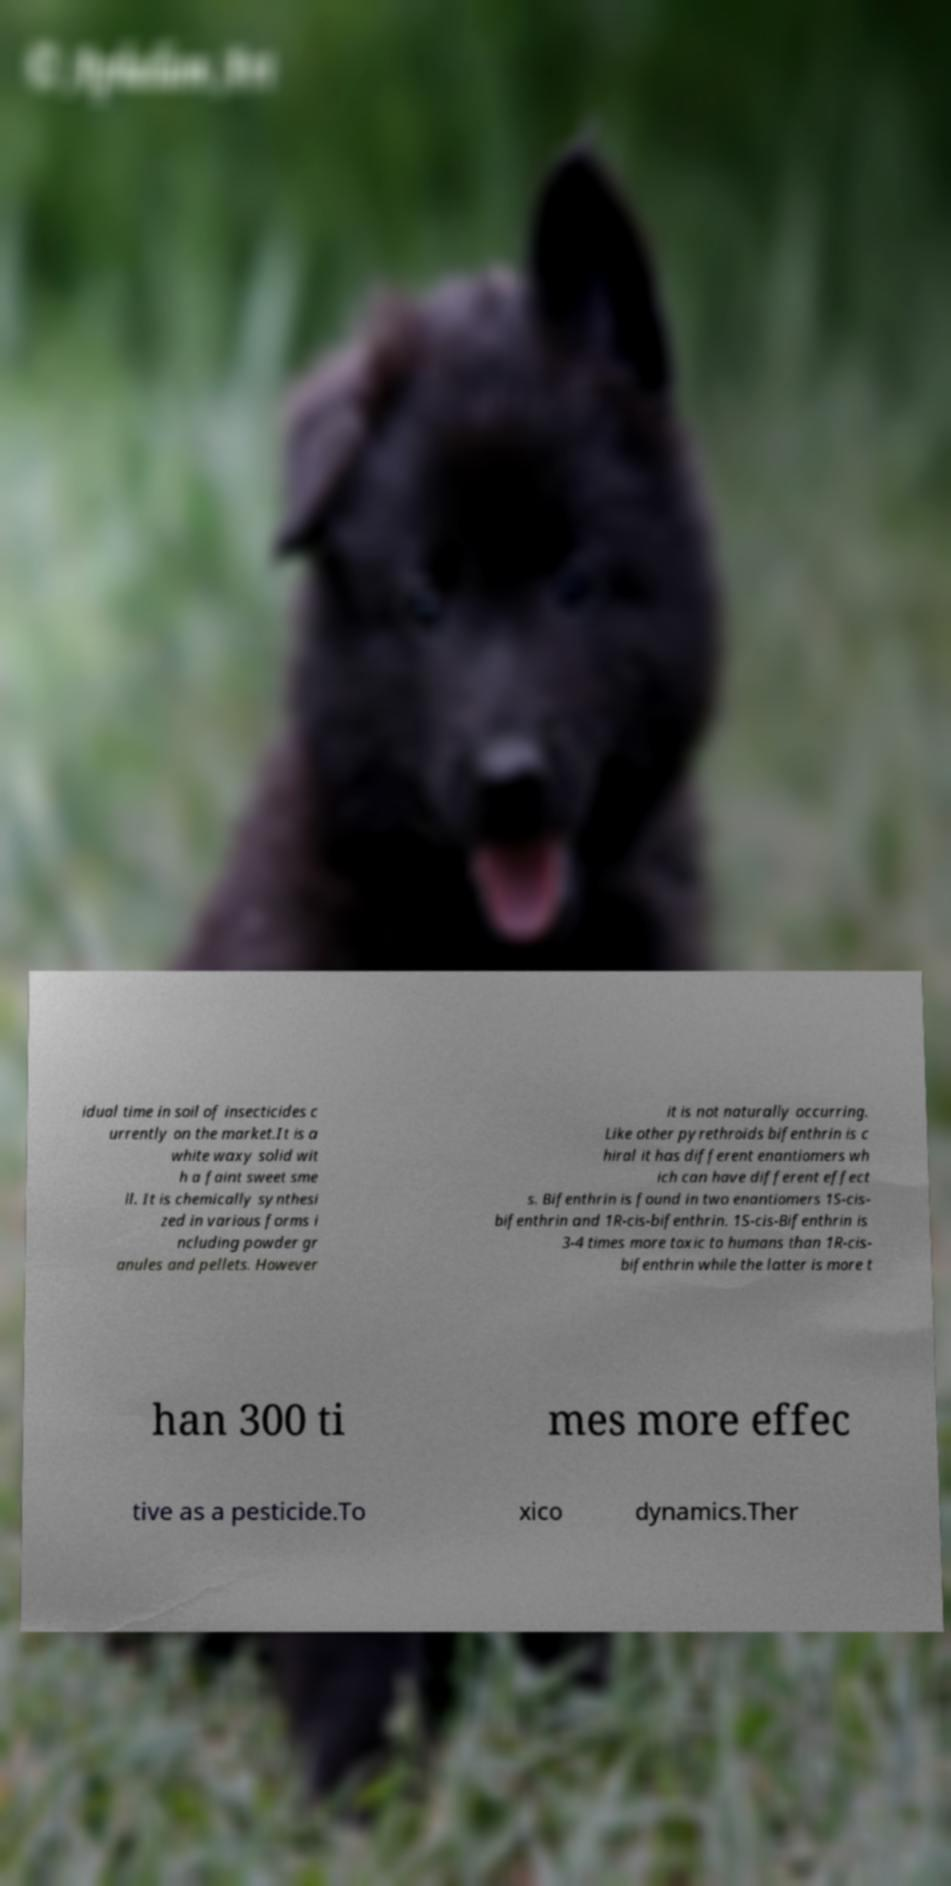What messages or text are displayed in this image? I need them in a readable, typed format. idual time in soil of insecticides c urrently on the market.It is a white waxy solid wit h a faint sweet sme ll. It is chemically synthesi zed in various forms i ncluding powder gr anules and pellets. However it is not naturally occurring. Like other pyrethroids bifenthrin is c hiral it has different enantiomers wh ich can have different effect s. Bifenthrin is found in two enantiomers 1S-cis- bifenthrin and 1R-cis-bifenthrin. 1S-cis-Bifenthrin is 3-4 times more toxic to humans than 1R-cis- bifenthrin while the latter is more t han 300 ti mes more effec tive as a pesticide.To xico dynamics.Ther 